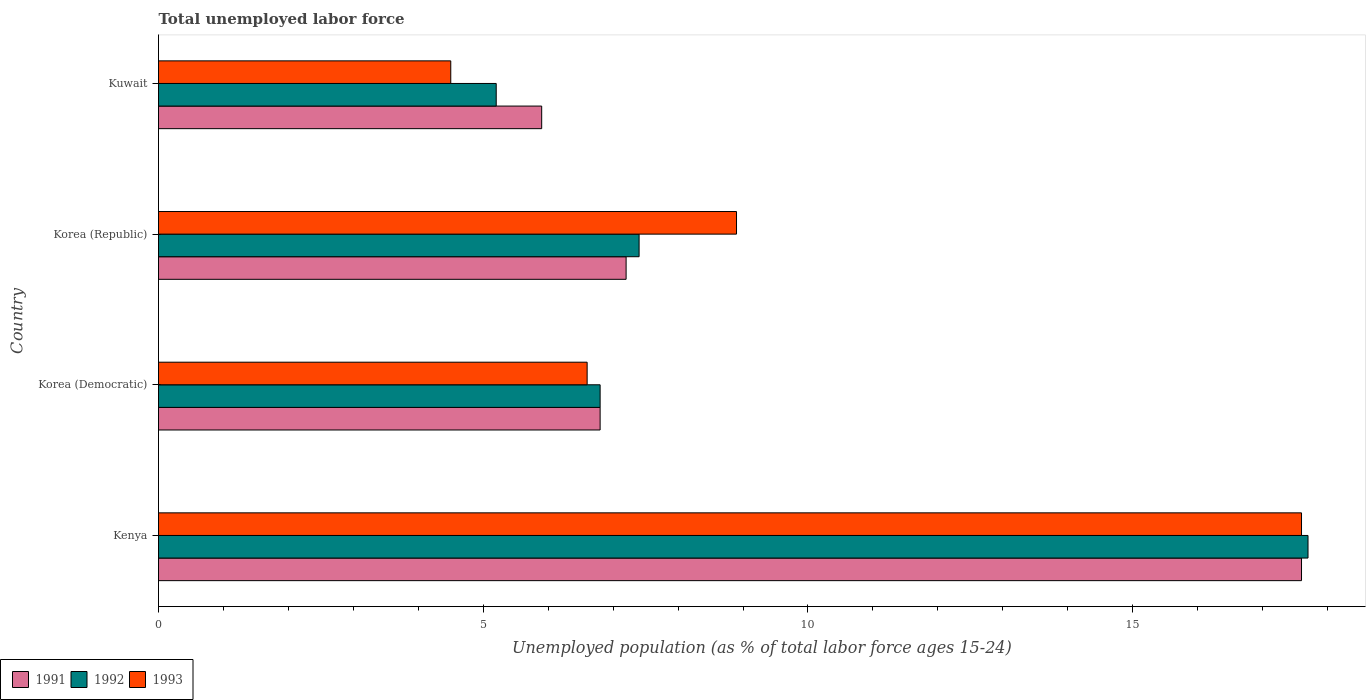How many groups of bars are there?
Ensure brevity in your answer.  4. Are the number of bars on each tick of the Y-axis equal?
Keep it short and to the point. Yes. How many bars are there on the 4th tick from the bottom?
Provide a succinct answer. 3. In how many cases, is the number of bars for a given country not equal to the number of legend labels?
Ensure brevity in your answer.  0. What is the percentage of unemployed population in in 1991 in Korea (Democratic)?
Provide a succinct answer. 6.8. Across all countries, what is the maximum percentage of unemployed population in in 1993?
Keep it short and to the point. 17.6. Across all countries, what is the minimum percentage of unemployed population in in 1993?
Ensure brevity in your answer.  4.5. In which country was the percentage of unemployed population in in 1991 maximum?
Your answer should be compact. Kenya. In which country was the percentage of unemployed population in in 1992 minimum?
Your answer should be compact. Kuwait. What is the total percentage of unemployed population in in 1993 in the graph?
Provide a short and direct response. 37.6. What is the difference between the percentage of unemployed population in in 1991 in Korea (Republic) and that in Kuwait?
Your answer should be compact. 1.3. What is the difference between the percentage of unemployed population in in 1991 in Korea (Democratic) and the percentage of unemployed population in in 1992 in Kuwait?
Provide a succinct answer. 1.6. What is the average percentage of unemployed population in in 1992 per country?
Keep it short and to the point. 9.28. What is the ratio of the percentage of unemployed population in in 1991 in Korea (Democratic) to that in Korea (Republic)?
Offer a terse response. 0.94. Is the percentage of unemployed population in in 1993 in Korea (Democratic) less than that in Korea (Republic)?
Your response must be concise. Yes. Is the difference between the percentage of unemployed population in in 1991 in Kenya and Korea (Democratic) greater than the difference between the percentage of unemployed population in in 1993 in Kenya and Korea (Democratic)?
Ensure brevity in your answer.  No. What is the difference between the highest and the second highest percentage of unemployed population in in 1992?
Your answer should be compact. 10.3. What is the difference between the highest and the lowest percentage of unemployed population in in 1993?
Ensure brevity in your answer.  13.1. Is the sum of the percentage of unemployed population in in 1992 in Korea (Democratic) and Kuwait greater than the maximum percentage of unemployed population in in 1993 across all countries?
Keep it short and to the point. No. What does the 2nd bar from the top in Korea (Republic) represents?
Provide a succinct answer. 1992. What does the 3rd bar from the bottom in Korea (Republic) represents?
Your answer should be very brief. 1993. Is it the case that in every country, the sum of the percentage of unemployed population in in 1993 and percentage of unemployed population in in 1991 is greater than the percentage of unemployed population in in 1992?
Keep it short and to the point. Yes. How many bars are there?
Your answer should be very brief. 12. How many countries are there in the graph?
Offer a terse response. 4. How many legend labels are there?
Give a very brief answer. 3. How are the legend labels stacked?
Give a very brief answer. Horizontal. What is the title of the graph?
Provide a short and direct response. Total unemployed labor force. Does "1971" appear as one of the legend labels in the graph?
Your answer should be compact. No. What is the label or title of the X-axis?
Make the answer very short. Unemployed population (as % of total labor force ages 15-24). What is the label or title of the Y-axis?
Provide a succinct answer. Country. What is the Unemployed population (as % of total labor force ages 15-24) of 1991 in Kenya?
Ensure brevity in your answer.  17.6. What is the Unemployed population (as % of total labor force ages 15-24) in 1992 in Kenya?
Make the answer very short. 17.7. What is the Unemployed population (as % of total labor force ages 15-24) of 1993 in Kenya?
Make the answer very short. 17.6. What is the Unemployed population (as % of total labor force ages 15-24) of 1991 in Korea (Democratic)?
Your answer should be very brief. 6.8. What is the Unemployed population (as % of total labor force ages 15-24) in 1992 in Korea (Democratic)?
Make the answer very short. 6.8. What is the Unemployed population (as % of total labor force ages 15-24) of 1993 in Korea (Democratic)?
Your response must be concise. 6.6. What is the Unemployed population (as % of total labor force ages 15-24) in 1991 in Korea (Republic)?
Ensure brevity in your answer.  7.2. What is the Unemployed population (as % of total labor force ages 15-24) in 1992 in Korea (Republic)?
Offer a terse response. 7.4. What is the Unemployed population (as % of total labor force ages 15-24) of 1993 in Korea (Republic)?
Your answer should be compact. 8.9. What is the Unemployed population (as % of total labor force ages 15-24) of 1991 in Kuwait?
Your response must be concise. 5.9. What is the Unemployed population (as % of total labor force ages 15-24) in 1992 in Kuwait?
Offer a very short reply. 5.2. Across all countries, what is the maximum Unemployed population (as % of total labor force ages 15-24) of 1991?
Offer a very short reply. 17.6. Across all countries, what is the maximum Unemployed population (as % of total labor force ages 15-24) in 1992?
Ensure brevity in your answer.  17.7. Across all countries, what is the maximum Unemployed population (as % of total labor force ages 15-24) in 1993?
Offer a very short reply. 17.6. Across all countries, what is the minimum Unemployed population (as % of total labor force ages 15-24) of 1991?
Ensure brevity in your answer.  5.9. Across all countries, what is the minimum Unemployed population (as % of total labor force ages 15-24) in 1992?
Your response must be concise. 5.2. What is the total Unemployed population (as % of total labor force ages 15-24) in 1991 in the graph?
Offer a terse response. 37.5. What is the total Unemployed population (as % of total labor force ages 15-24) in 1992 in the graph?
Your answer should be compact. 37.1. What is the total Unemployed population (as % of total labor force ages 15-24) in 1993 in the graph?
Give a very brief answer. 37.6. What is the difference between the Unemployed population (as % of total labor force ages 15-24) in 1991 in Kenya and that in Korea (Democratic)?
Offer a terse response. 10.8. What is the difference between the Unemployed population (as % of total labor force ages 15-24) in 1993 in Kenya and that in Korea (Democratic)?
Your answer should be compact. 11. What is the difference between the Unemployed population (as % of total labor force ages 15-24) in 1992 in Kenya and that in Korea (Republic)?
Ensure brevity in your answer.  10.3. What is the difference between the Unemployed population (as % of total labor force ages 15-24) in 1993 in Kenya and that in Korea (Republic)?
Your answer should be very brief. 8.7. What is the difference between the Unemployed population (as % of total labor force ages 15-24) in 1992 in Kenya and that in Kuwait?
Offer a very short reply. 12.5. What is the difference between the Unemployed population (as % of total labor force ages 15-24) in 1993 in Kenya and that in Kuwait?
Your answer should be compact. 13.1. What is the difference between the Unemployed population (as % of total labor force ages 15-24) in 1991 in Korea (Democratic) and that in Korea (Republic)?
Your answer should be very brief. -0.4. What is the difference between the Unemployed population (as % of total labor force ages 15-24) in 1992 in Korea (Democratic) and that in Korea (Republic)?
Your answer should be very brief. -0.6. What is the difference between the Unemployed population (as % of total labor force ages 15-24) in 1993 in Korea (Democratic) and that in Kuwait?
Your answer should be very brief. 2.1. What is the difference between the Unemployed population (as % of total labor force ages 15-24) in 1991 in Korea (Republic) and that in Kuwait?
Your answer should be very brief. 1.3. What is the difference between the Unemployed population (as % of total labor force ages 15-24) in 1991 in Kenya and the Unemployed population (as % of total labor force ages 15-24) in 1992 in Korea (Democratic)?
Provide a short and direct response. 10.8. What is the difference between the Unemployed population (as % of total labor force ages 15-24) in 1992 in Kenya and the Unemployed population (as % of total labor force ages 15-24) in 1993 in Korea (Democratic)?
Offer a terse response. 11.1. What is the difference between the Unemployed population (as % of total labor force ages 15-24) in 1991 in Kenya and the Unemployed population (as % of total labor force ages 15-24) in 1992 in Korea (Republic)?
Your answer should be very brief. 10.2. What is the difference between the Unemployed population (as % of total labor force ages 15-24) of 1991 in Korea (Democratic) and the Unemployed population (as % of total labor force ages 15-24) of 1992 in Kuwait?
Your answer should be compact. 1.6. What is the difference between the Unemployed population (as % of total labor force ages 15-24) of 1991 in Korea (Democratic) and the Unemployed population (as % of total labor force ages 15-24) of 1993 in Kuwait?
Make the answer very short. 2.3. What is the difference between the Unemployed population (as % of total labor force ages 15-24) of 1992 in Korea (Republic) and the Unemployed population (as % of total labor force ages 15-24) of 1993 in Kuwait?
Provide a succinct answer. 2.9. What is the average Unemployed population (as % of total labor force ages 15-24) in 1991 per country?
Make the answer very short. 9.38. What is the average Unemployed population (as % of total labor force ages 15-24) of 1992 per country?
Your response must be concise. 9.28. What is the average Unemployed population (as % of total labor force ages 15-24) in 1993 per country?
Provide a short and direct response. 9.4. What is the difference between the Unemployed population (as % of total labor force ages 15-24) in 1992 and Unemployed population (as % of total labor force ages 15-24) in 1993 in Kenya?
Provide a succinct answer. 0.1. What is the difference between the Unemployed population (as % of total labor force ages 15-24) of 1991 and Unemployed population (as % of total labor force ages 15-24) of 1993 in Korea (Republic)?
Keep it short and to the point. -1.7. What is the difference between the Unemployed population (as % of total labor force ages 15-24) of 1992 and Unemployed population (as % of total labor force ages 15-24) of 1993 in Korea (Republic)?
Give a very brief answer. -1.5. What is the difference between the Unemployed population (as % of total labor force ages 15-24) of 1992 and Unemployed population (as % of total labor force ages 15-24) of 1993 in Kuwait?
Keep it short and to the point. 0.7. What is the ratio of the Unemployed population (as % of total labor force ages 15-24) in 1991 in Kenya to that in Korea (Democratic)?
Offer a terse response. 2.59. What is the ratio of the Unemployed population (as % of total labor force ages 15-24) of 1992 in Kenya to that in Korea (Democratic)?
Provide a short and direct response. 2.6. What is the ratio of the Unemployed population (as % of total labor force ages 15-24) of 1993 in Kenya to that in Korea (Democratic)?
Your answer should be very brief. 2.67. What is the ratio of the Unemployed population (as % of total labor force ages 15-24) of 1991 in Kenya to that in Korea (Republic)?
Ensure brevity in your answer.  2.44. What is the ratio of the Unemployed population (as % of total labor force ages 15-24) in 1992 in Kenya to that in Korea (Republic)?
Your answer should be very brief. 2.39. What is the ratio of the Unemployed population (as % of total labor force ages 15-24) in 1993 in Kenya to that in Korea (Republic)?
Provide a succinct answer. 1.98. What is the ratio of the Unemployed population (as % of total labor force ages 15-24) in 1991 in Kenya to that in Kuwait?
Your answer should be very brief. 2.98. What is the ratio of the Unemployed population (as % of total labor force ages 15-24) of 1992 in Kenya to that in Kuwait?
Ensure brevity in your answer.  3.4. What is the ratio of the Unemployed population (as % of total labor force ages 15-24) in 1993 in Kenya to that in Kuwait?
Give a very brief answer. 3.91. What is the ratio of the Unemployed population (as % of total labor force ages 15-24) in 1992 in Korea (Democratic) to that in Korea (Republic)?
Ensure brevity in your answer.  0.92. What is the ratio of the Unemployed population (as % of total labor force ages 15-24) of 1993 in Korea (Democratic) to that in Korea (Republic)?
Provide a succinct answer. 0.74. What is the ratio of the Unemployed population (as % of total labor force ages 15-24) in 1991 in Korea (Democratic) to that in Kuwait?
Provide a short and direct response. 1.15. What is the ratio of the Unemployed population (as % of total labor force ages 15-24) in 1992 in Korea (Democratic) to that in Kuwait?
Ensure brevity in your answer.  1.31. What is the ratio of the Unemployed population (as % of total labor force ages 15-24) in 1993 in Korea (Democratic) to that in Kuwait?
Provide a succinct answer. 1.47. What is the ratio of the Unemployed population (as % of total labor force ages 15-24) in 1991 in Korea (Republic) to that in Kuwait?
Give a very brief answer. 1.22. What is the ratio of the Unemployed population (as % of total labor force ages 15-24) in 1992 in Korea (Republic) to that in Kuwait?
Offer a terse response. 1.42. What is the ratio of the Unemployed population (as % of total labor force ages 15-24) in 1993 in Korea (Republic) to that in Kuwait?
Your answer should be compact. 1.98. What is the difference between the highest and the second highest Unemployed population (as % of total labor force ages 15-24) of 1991?
Your answer should be compact. 10.4. What is the difference between the highest and the second highest Unemployed population (as % of total labor force ages 15-24) in 1992?
Give a very brief answer. 10.3. What is the difference between the highest and the lowest Unemployed population (as % of total labor force ages 15-24) in 1992?
Give a very brief answer. 12.5. What is the difference between the highest and the lowest Unemployed population (as % of total labor force ages 15-24) in 1993?
Offer a terse response. 13.1. 